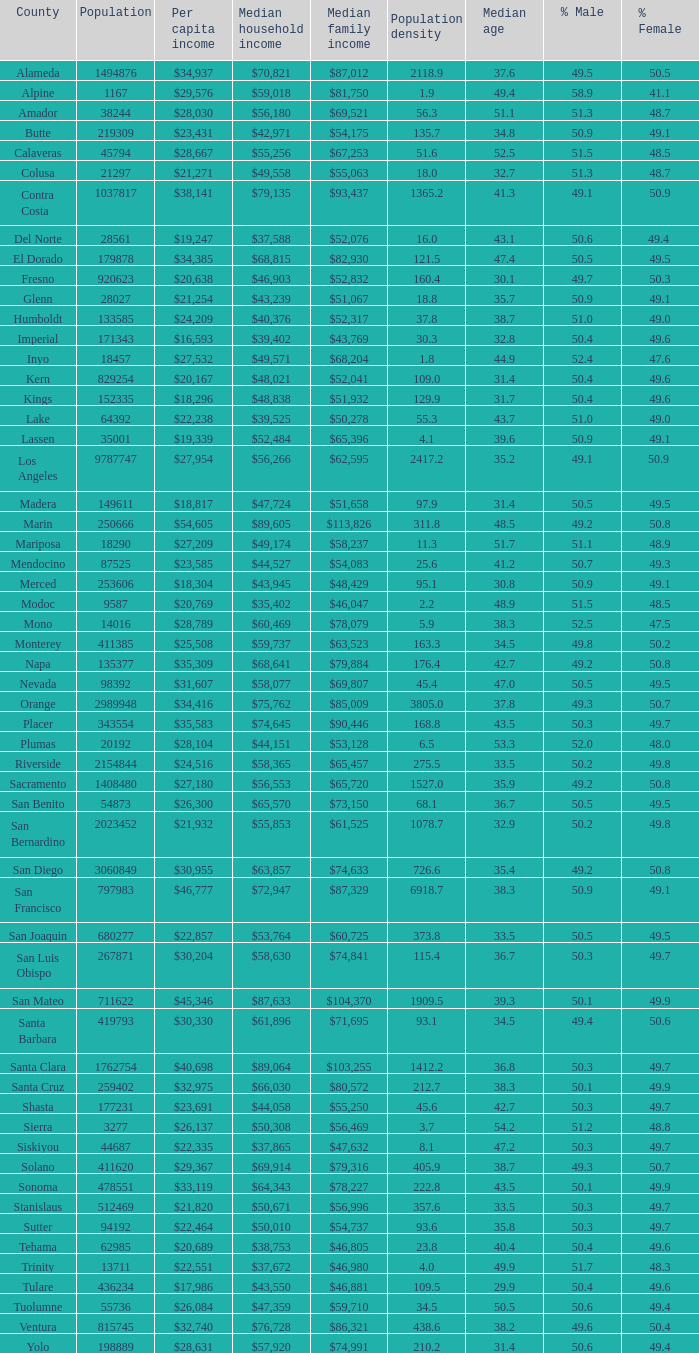What is the per capita income of shasta? $23,691. 